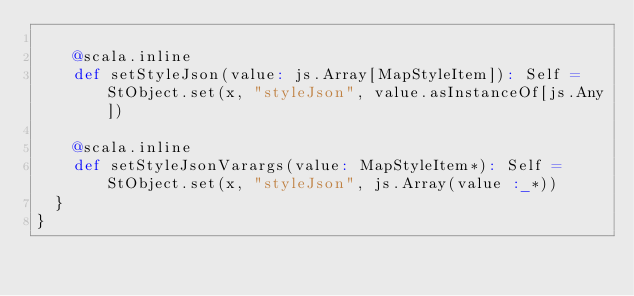Convert code to text. <code><loc_0><loc_0><loc_500><loc_500><_Scala_>    
    @scala.inline
    def setStyleJson(value: js.Array[MapStyleItem]): Self = StObject.set(x, "styleJson", value.asInstanceOf[js.Any])
    
    @scala.inline
    def setStyleJsonVarargs(value: MapStyleItem*): Self = StObject.set(x, "styleJson", js.Array(value :_*))
  }
}
</code> 